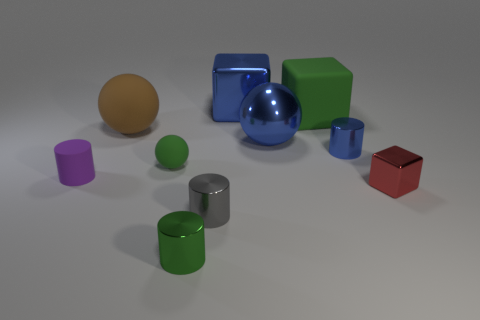Subtract 1 cylinders. How many cylinders are left? 3 Subtract all gray cylinders. Subtract all purple blocks. How many cylinders are left? 3 Subtract all blocks. How many objects are left? 7 Subtract 0 yellow spheres. How many objects are left? 10 Subtract all blue metal balls. Subtract all big green rubber cubes. How many objects are left? 8 Add 5 red metal objects. How many red metal objects are left? 6 Add 6 big green objects. How many big green objects exist? 7 